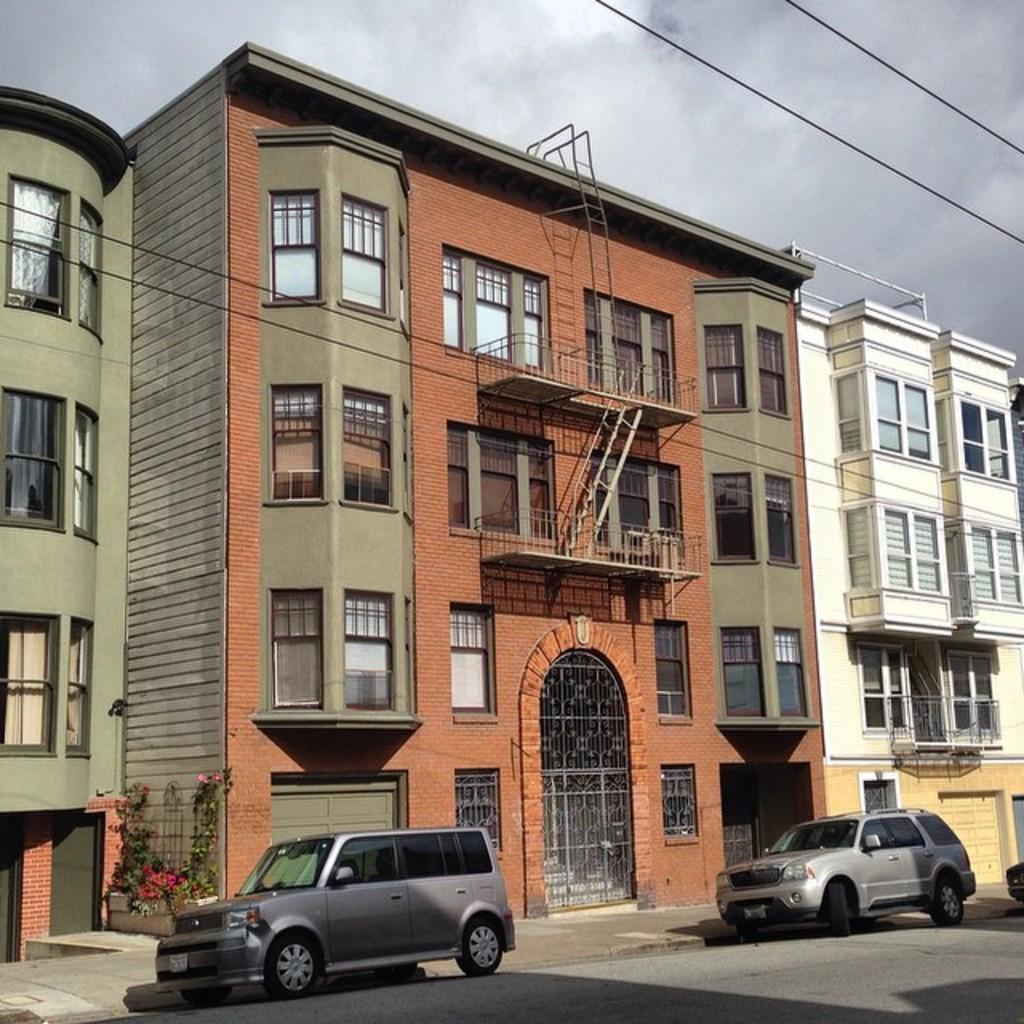In one or two sentences, can you explain what this image depicts? In this picture we can see two cars in the front, there are buildings in the background, on the left side we can see plants, there is the sky at the top of the picture. 